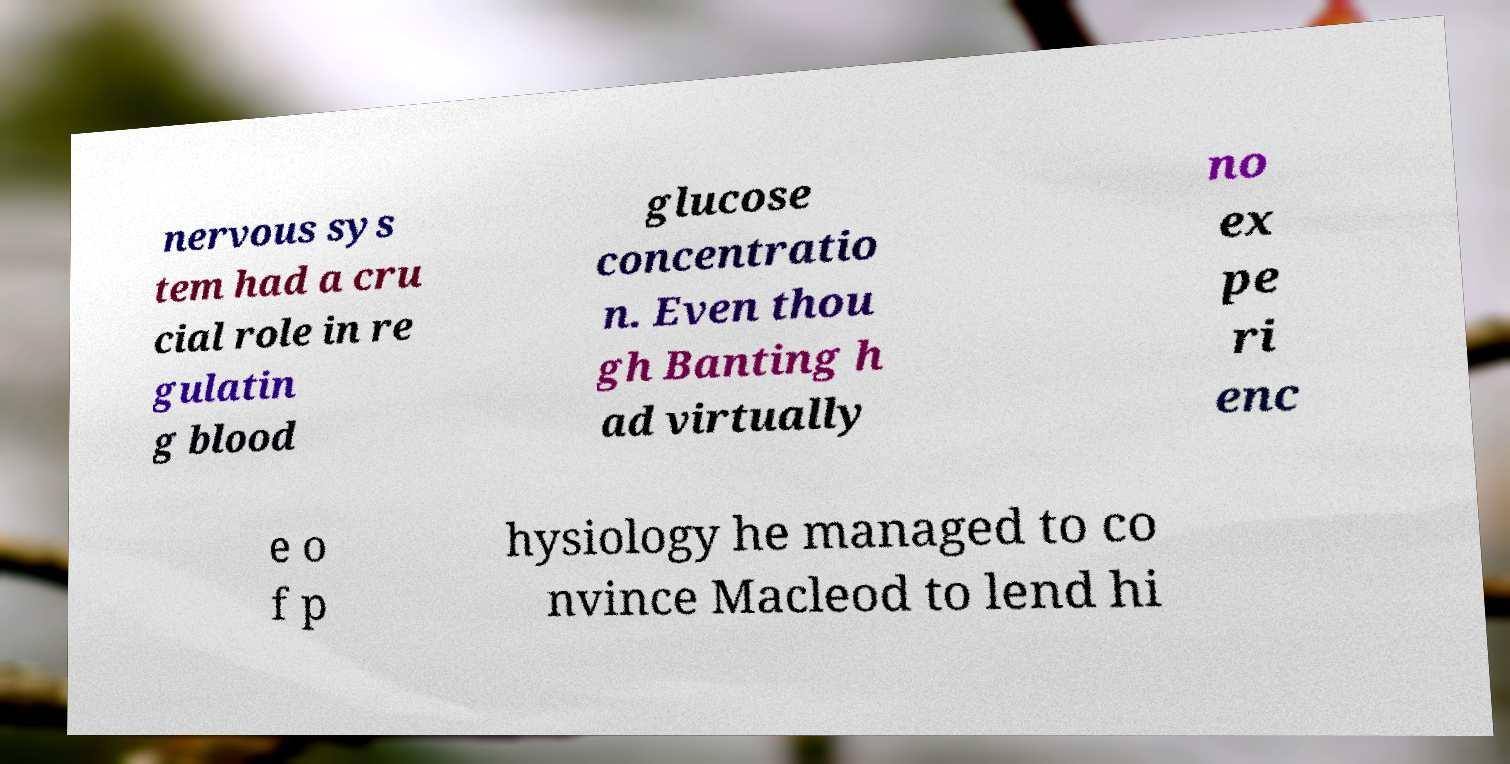Can you accurately transcribe the text from the provided image for me? nervous sys tem had a cru cial role in re gulatin g blood glucose concentratio n. Even thou gh Banting h ad virtually no ex pe ri enc e o f p hysiology he managed to co nvince Macleod to lend hi 